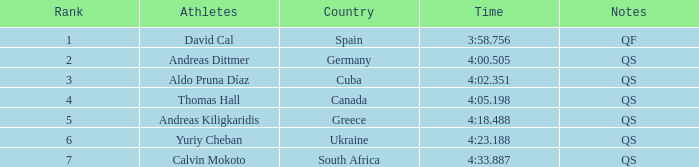Help me parse the entirety of this table. {'header': ['Rank', 'Athletes', 'Country', 'Time', 'Notes'], 'rows': [['1', 'David Cal', 'Spain', '3:58.756', 'QF'], ['2', 'Andreas Dittmer', 'Germany', '4:00.505', 'QS'], ['3', 'Aldo Pruna Díaz', 'Cuba', '4:02.351', 'QS'], ['4', 'Thomas Hall', 'Canada', '4:05.198', 'QS'], ['5', 'Andreas Kiligkaridis', 'Greece', '4:18.488', 'QS'], ['6', 'Yuriy Cheban', 'Ukraine', '4:23.188', 'QS'], ['7', 'Calvin Mokoto', 'South Africa', '4:33.887', 'QS']]} What are the notes for the athlete from South Africa? QS. 